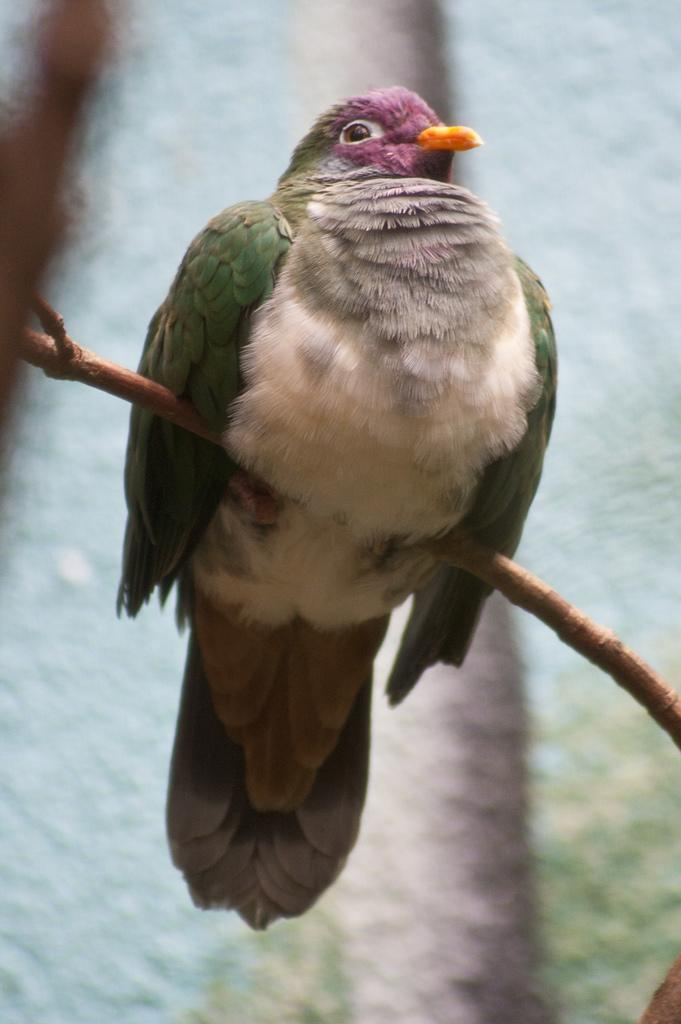What type of animal can be seen in the image? There is a bird in the image. Where is the bird located in the image? The bird is standing on the stem of a plant. What type of suit is the bird wearing in the image? There is no suit present in the image, as birds do not wear clothing. 